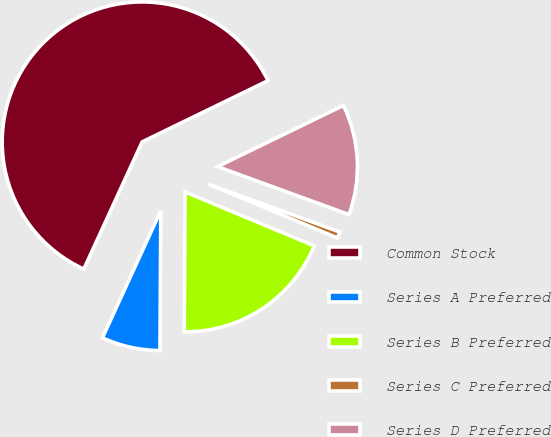<chart> <loc_0><loc_0><loc_500><loc_500><pie_chart><fcel>Common Stock<fcel>Series A Preferred<fcel>Series B Preferred<fcel>Series C Preferred<fcel>Series D Preferred<nl><fcel>60.95%<fcel>6.75%<fcel>18.8%<fcel>0.73%<fcel>12.77%<nl></chart> 